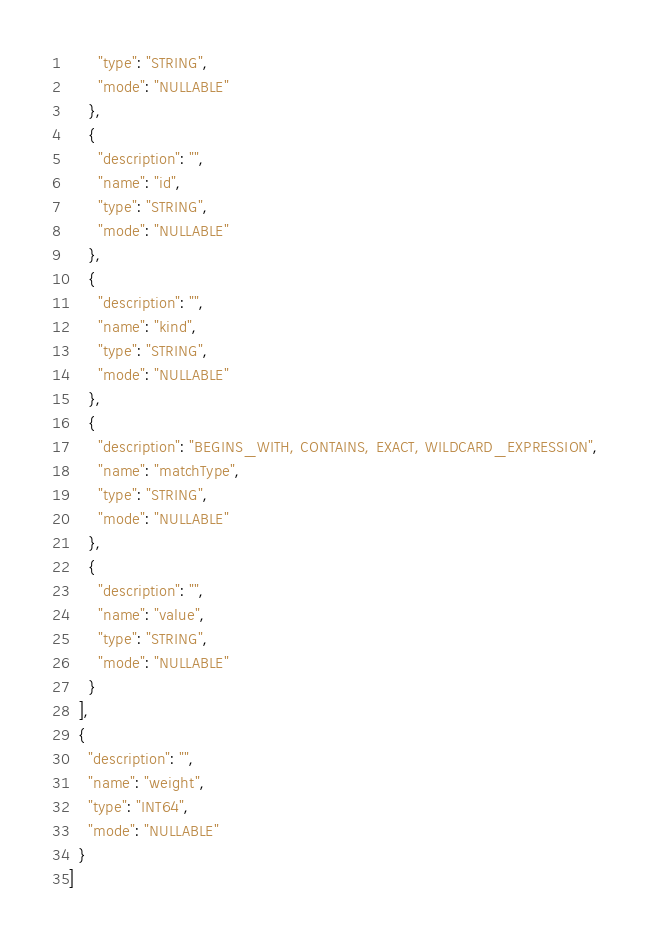<code> <loc_0><loc_0><loc_500><loc_500><_Python_>      "type": "STRING",
      "mode": "NULLABLE"
    },
    {
      "description": "",
      "name": "id",
      "type": "STRING",
      "mode": "NULLABLE"
    },
    {
      "description": "",
      "name": "kind",
      "type": "STRING",
      "mode": "NULLABLE"
    },
    {
      "description": "BEGINS_WITH, CONTAINS, EXACT, WILDCARD_EXPRESSION",
      "name": "matchType",
      "type": "STRING",
      "mode": "NULLABLE"
    },
    {
      "description": "",
      "name": "value",
      "type": "STRING",
      "mode": "NULLABLE"
    }
  ],
  {
    "description": "",
    "name": "weight",
    "type": "INT64",
    "mode": "NULLABLE"
  }
]
</code> 